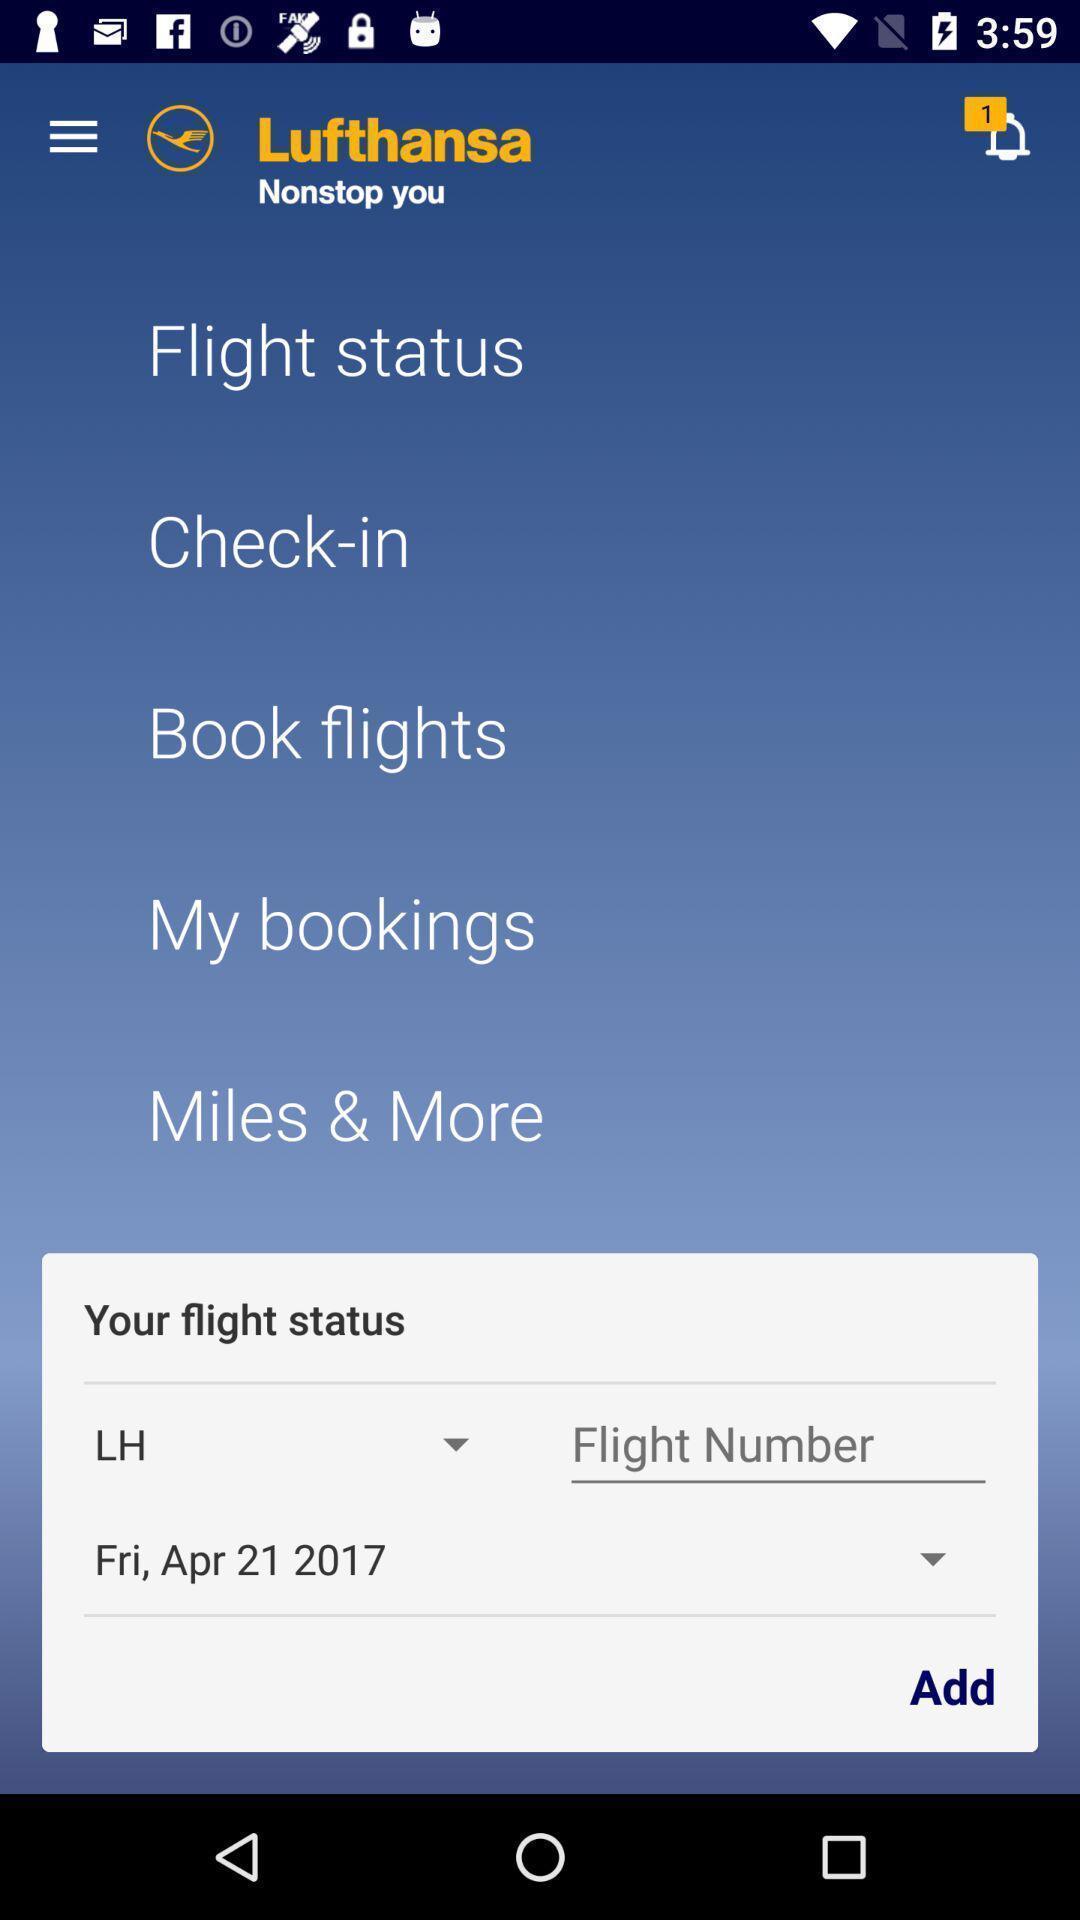Describe the visual elements of this screenshot. Page that displaying travel application. 